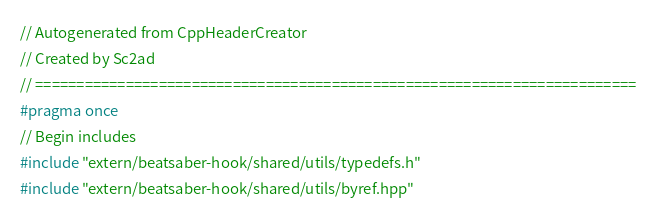<code> <loc_0><loc_0><loc_500><loc_500><_C++_>// Autogenerated from CppHeaderCreator
// Created by Sc2ad
// =========================================================================
#pragma once
// Begin includes
#include "extern/beatsaber-hook/shared/utils/typedefs.h"
#include "extern/beatsaber-hook/shared/utils/byref.hpp"</code> 